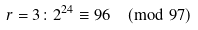<formula> <loc_0><loc_0><loc_500><loc_500>r = 3 \colon 2 ^ { 2 4 } \equiv 9 6 { \pmod { 9 7 } }</formula> 